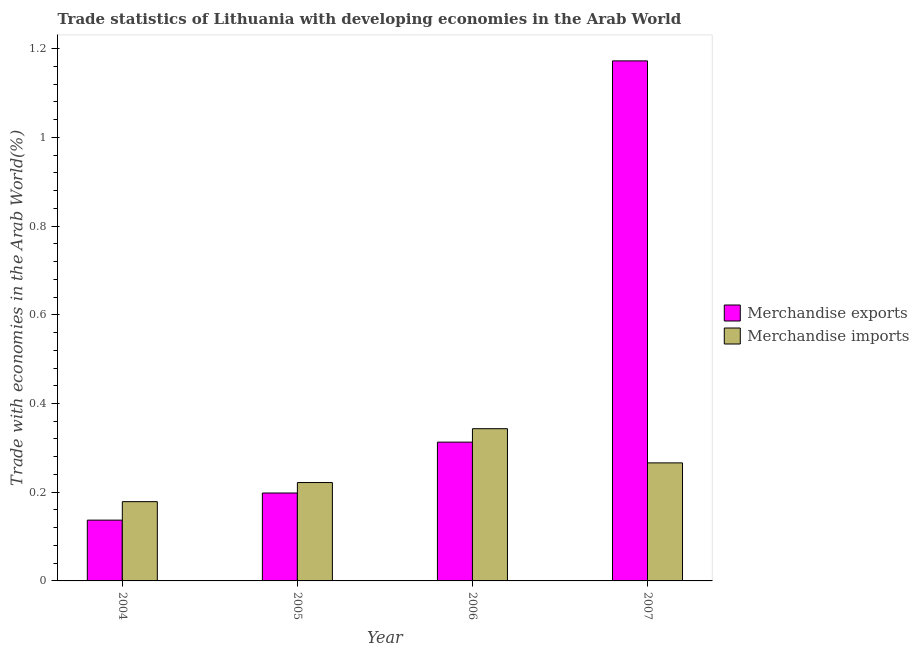How many different coloured bars are there?
Your answer should be compact. 2. How many groups of bars are there?
Your answer should be very brief. 4. Are the number of bars on each tick of the X-axis equal?
Offer a very short reply. Yes. How many bars are there on the 4th tick from the left?
Your answer should be very brief. 2. How many bars are there on the 1st tick from the right?
Offer a terse response. 2. What is the label of the 3rd group of bars from the left?
Keep it short and to the point. 2006. In how many cases, is the number of bars for a given year not equal to the number of legend labels?
Offer a terse response. 0. What is the merchandise exports in 2006?
Offer a very short reply. 0.31. Across all years, what is the maximum merchandise imports?
Offer a terse response. 0.34. Across all years, what is the minimum merchandise imports?
Ensure brevity in your answer.  0.18. What is the total merchandise imports in the graph?
Offer a terse response. 1.01. What is the difference between the merchandise imports in 2005 and that in 2006?
Ensure brevity in your answer.  -0.12. What is the difference between the merchandise exports in 2006 and the merchandise imports in 2004?
Ensure brevity in your answer.  0.18. What is the average merchandise imports per year?
Your answer should be very brief. 0.25. In how many years, is the merchandise exports greater than 1.12 %?
Your answer should be very brief. 1. What is the ratio of the merchandise imports in 2004 to that in 2006?
Provide a succinct answer. 0.52. Is the merchandise exports in 2004 less than that in 2007?
Provide a succinct answer. Yes. What is the difference between the highest and the second highest merchandise imports?
Your answer should be compact. 0.08. What is the difference between the highest and the lowest merchandise exports?
Offer a terse response. 1.04. In how many years, is the merchandise exports greater than the average merchandise exports taken over all years?
Keep it short and to the point. 1. What does the 1st bar from the left in 2005 represents?
Your answer should be very brief. Merchandise exports. What is the difference between two consecutive major ticks on the Y-axis?
Make the answer very short. 0.2. Does the graph contain grids?
Offer a terse response. No. Where does the legend appear in the graph?
Offer a terse response. Center right. What is the title of the graph?
Offer a very short reply. Trade statistics of Lithuania with developing economies in the Arab World. Does "Methane" appear as one of the legend labels in the graph?
Offer a very short reply. No. What is the label or title of the Y-axis?
Keep it short and to the point. Trade with economies in the Arab World(%). What is the Trade with economies in the Arab World(%) of Merchandise exports in 2004?
Offer a terse response. 0.14. What is the Trade with economies in the Arab World(%) of Merchandise imports in 2004?
Give a very brief answer. 0.18. What is the Trade with economies in the Arab World(%) of Merchandise exports in 2005?
Your answer should be compact. 0.2. What is the Trade with economies in the Arab World(%) of Merchandise imports in 2005?
Offer a very short reply. 0.22. What is the Trade with economies in the Arab World(%) in Merchandise exports in 2006?
Your response must be concise. 0.31. What is the Trade with economies in the Arab World(%) in Merchandise imports in 2006?
Your answer should be very brief. 0.34. What is the Trade with economies in the Arab World(%) of Merchandise exports in 2007?
Give a very brief answer. 1.17. What is the Trade with economies in the Arab World(%) of Merchandise imports in 2007?
Offer a terse response. 0.27. Across all years, what is the maximum Trade with economies in the Arab World(%) of Merchandise exports?
Your answer should be compact. 1.17. Across all years, what is the maximum Trade with economies in the Arab World(%) in Merchandise imports?
Provide a short and direct response. 0.34. Across all years, what is the minimum Trade with economies in the Arab World(%) in Merchandise exports?
Your response must be concise. 0.14. Across all years, what is the minimum Trade with economies in the Arab World(%) of Merchandise imports?
Your answer should be very brief. 0.18. What is the total Trade with economies in the Arab World(%) in Merchandise exports in the graph?
Your response must be concise. 1.82. What is the total Trade with economies in the Arab World(%) of Merchandise imports in the graph?
Your answer should be compact. 1.01. What is the difference between the Trade with economies in the Arab World(%) in Merchandise exports in 2004 and that in 2005?
Your answer should be very brief. -0.06. What is the difference between the Trade with economies in the Arab World(%) of Merchandise imports in 2004 and that in 2005?
Your answer should be compact. -0.04. What is the difference between the Trade with economies in the Arab World(%) in Merchandise exports in 2004 and that in 2006?
Provide a succinct answer. -0.18. What is the difference between the Trade with economies in the Arab World(%) of Merchandise imports in 2004 and that in 2006?
Offer a very short reply. -0.16. What is the difference between the Trade with economies in the Arab World(%) of Merchandise exports in 2004 and that in 2007?
Give a very brief answer. -1.04. What is the difference between the Trade with economies in the Arab World(%) of Merchandise imports in 2004 and that in 2007?
Your answer should be compact. -0.09. What is the difference between the Trade with economies in the Arab World(%) of Merchandise exports in 2005 and that in 2006?
Give a very brief answer. -0.11. What is the difference between the Trade with economies in the Arab World(%) in Merchandise imports in 2005 and that in 2006?
Ensure brevity in your answer.  -0.12. What is the difference between the Trade with economies in the Arab World(%) of Merchandise exports in 2005 and that in 2007?
Keep it short and to the point. -0.97. What is the difference between the Trade with economies in the Arab World(%) of Merchandise imports in 2005 and that in 2007?
Make the answer very short. -0.04. What is the difference between the Trade with economies in the Arab World(%) in Merchandise exports in 2006 and that in 2007?
Your answer should be very brief. -0.86. What is the difference between the Trade with economies in the Arab World(%) in Merchandise imports in 2006 and that in 2007?
Ensure brevity in your answer.  0.08. What is the difference between the Trade with economies in the Arab World(%) in Merchandise exports in 2004 and the Trade with economies in the Arab World(%) in Merchandise imports in 2005?
Your response must be concise. -0.08. What is the difference between the Trade with economies in the Arab World(%) in Merchandise exports in 2004 and the Trade with economies in the Arab World(%) in Merchandise imports in 2006?
Provide a succinct answer. -0.21. What is the difference between the Trade with economies in the Arab World(%) in Merchandise exports in 2004 and the Trade with economies in the Arab World(%) in Merchandise imports in 2007?
Ensure brevity in your answer.  -0.13. What is the difference between the Trade with economies in the Arab World(%) in Merchandise exports in 2005 and the Trade with economies in the Arab World(%) in Merchandise imports in 2006?
Your response must be concise. -0.14. What is the difference between the Trade with economies in the Arab World(%) in Merchandise exports in 2005 and the Trade with economies in the Arab World(%) in Merchandise imports in 2007?
Your response must be concise. -0.07. What is the difference between the Trade with economies in the Arab World(%) of Merchandise exports in 2006 and the Trade with economies in the Arab World(%) of Merchandise imports in 2007?
Your answer should be very brief. 0.05. What is the average Trade with economies in the Arab World(%) of Merchandise exports per year?
Give a very brief answer. 0.46. What is the average Trade with economies in the Arab World(%) in Merchandise imports per year?
Offer a very short reply. 0.25. In the year 2004, what is the difference between the Trade with economies in the Arab World(%) in Merchandise exports and Trade with economies in the Arab World(%) in Merchandise imports?
Give a very brief answer. -0.04. In the year 2005, what is the difference between the Trade with economies in the Arab World(%) of Merchandise exports and Trade with economies in the Arab World(%) of Merchandise imports?
Provide a short and direct response. -0.02. In the year 2006, what is the difference between the Trade with economies in the Arab World(%) of Merchandise exports and Trade with economies in the Arab World(%) of Merchandise imports?
Give a very brief answer. -0.03. In the year 2007, what is the difference between the Trade with economies in the Arab World(%) of Merchandise exports and Trade with economies in the Arab World(%) of Merchandise imports?
Your answer should be very brief. 0.91. What is the ratio of the Trade with economies in the Arab World(%) of Merchandise exports in 2004 to that in 2005?
Offer a terse response. 0.69. What is the ratio of the Trade with economies in the Arab World(%) in Merchandise imports in 2004 to that in 2005?
Give a very brief answer. 0.81. What is the ratio of the Trade with economies in the Arab World(%) of Merchandise exports in 2004 to that in 2006?
Keep it short and to the point. 0.44. What is the ratio of the Trade with economies in the Arab World(%) of Merchandise imports in 2004 to that in 2006?
Give a very brief answer. 0.52. What is the ratio of the Trade with economies in the Arab World(%) in Merchandise exports in 2004 to that in 2007?
Offer a terse response. 0.12. What is the ratio of the Trade with economies in the Arab World(%) of Merchandise imports in 2004 to that in 2007?
Ensure brevity in your answer.  0.67. What is the ratio of the Trade with economies in the Arab World(%) in Merchandise exports in 2005 to that in 2006?
Your response must be concise. 0.63. What is the ratio of the Trade with economies in the Arab World(%) of Merchandise imports in 2005 to that in 2006?
Offer a terse response. 0.65. What is the ratio of the Trade with economies in the Arab World(%) of Merchandise exports in 2005 to that in 2007?
Offer a terse response. 0.17. What is the ratio of the Trade with economies in the Arab World(%) in Merchandise imports in 2005 to that in 2007?
Keep it short and to the point. 0.83. What is the ratio of the Trade with economies in the Arab World(%) in Merchandise exports in 2006 to that in 2007?
Make the answer very short. 0.27. What is the ratio of the Trade with economies in the Arab World(%) in Merchandise imports in 2006 to that in 2007?
Your answer should be very brief. 1.29. What is the difference between the highest and the second highest Trade with economies in the Arab World(%) in Merchandise exports?
Ensure brevity in your answer.  0.86. What is the difference between the highest and the second highest Trade with economies in the Arab World(%) of Merchandise imports?
Provide a succinct answer. 0.08. What is the difference between the highest and the lowest Trade with economies in the Arab World(%) in Merchandise exports?
Offer a very short reply. 1.04. What is the difference between the highest and the lowest Trade with economies in the Arab World(%) of Merchandise imports?
Your answer should be compact. 0.16. 